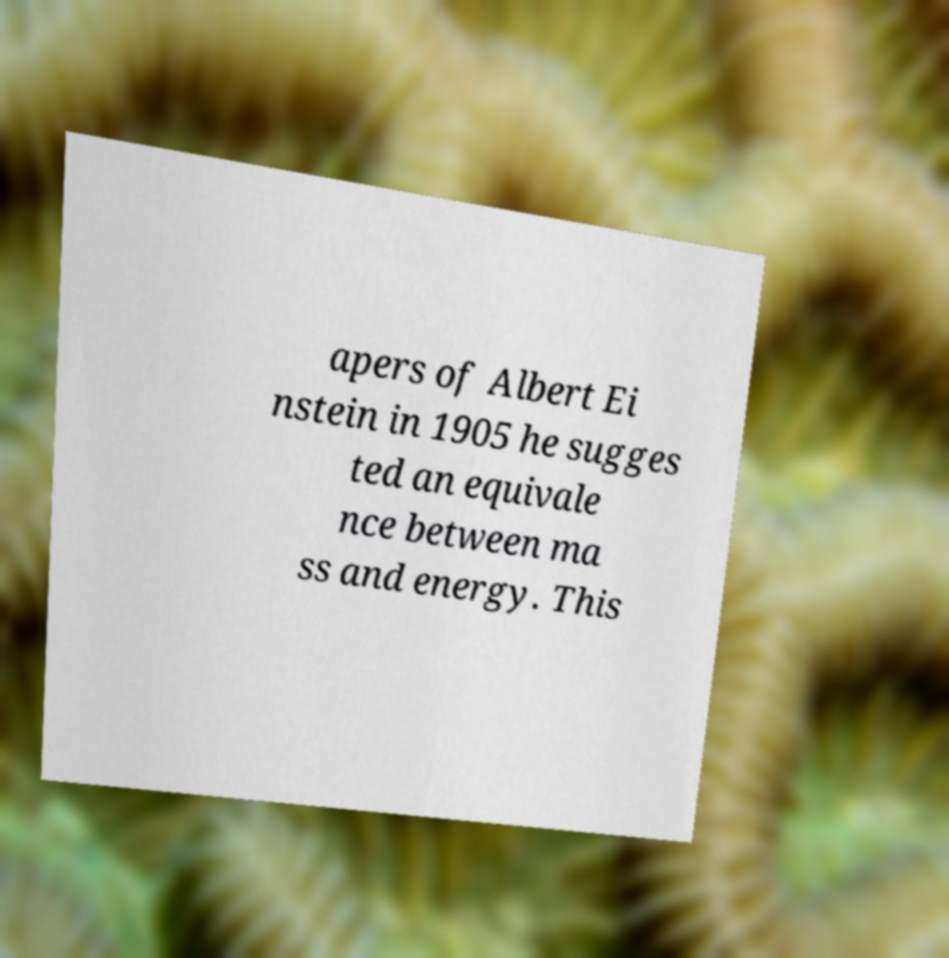I need the written content from this picture converted into text. Can you do that? apers of Albert Ei nstein in 1905 he sugges ted an equivale nce between ma ss and energy. This 